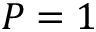<formula> <loc_0><loc_0><loc_500><loc_500>P = 1</formula> 